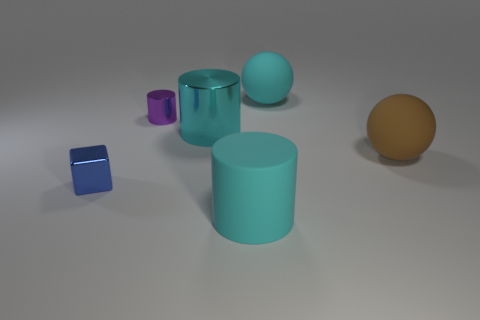Add 1 metal blocks. How many objects exist? 7 Subtract all cubes. How many objects are left? 5 Subtract 0 red cylinders. How many objects are left? 6 Subtract all brown matte things. Subtract all tiny purple metallic blocks. How many objects are left? 5 Add 2 small purple metal cylinders. How many small purple metal cylinders are left? 3 Add 4 tiny red cubes. How many tiny red cubes exist? 4 